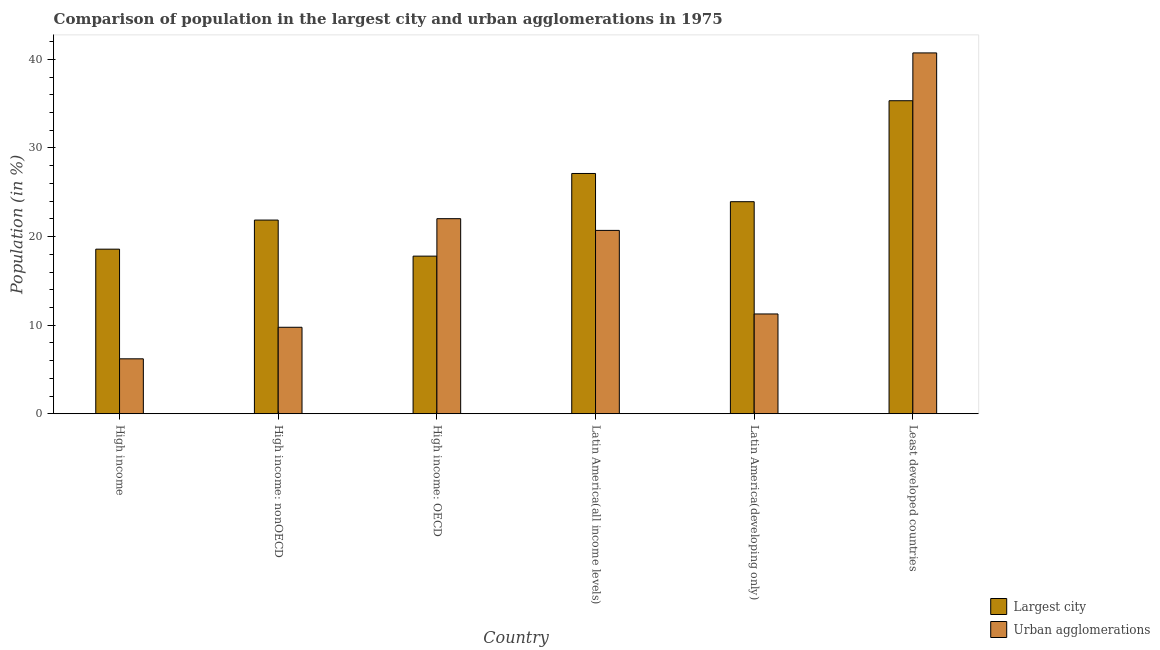How many groups of bars are there?
Ensure brevity in your answer.  6. Are the number of bars per tick equal to the number of legend labels?
Your answer should be compact. Yes. How many bars are there on the 6th tick from the right?
Offer a very short reply. 2. What is the label of the 6th group of bars from the left?
Make the answer very short. Least developed countries. In how many cases, is the number of bars for a given country not equal to the number of legend labels?
Offer a terse response. 0. What is the population in the largest city in Least developed countries?
Provide a succinct answer. 35.34. Across all countries, what is the maximum population in urban agglomerations?
Give a very brief answer. 40.73. Across all countries, what is the minimum population in urban agglomerations?
Provide a succinct answer. 6.2. In which country was the population in the largest city maximum?
Provide a short and direct response. Least developed countries. In which country was the population in the largest city minimum?
Keep it short and to the point. High income: OECD. What is the total population in the largest city in the graph?
Provide a succinct answer. 144.63. What is the difference between the population in the largest city in High income: OECD and that in Latin America(all income levels)?
Keep it short and to the point. -9.33. What is the difference between the population in urban agglomerations in Latin America(all income levels) and the population in the largest city in High income: nonOECD?
Keep it short and to the point. -1.17. What is the average population in urban agglomerations per country?
Provide a short and direct response. 18.45. What is the difference between the population in the largest city and population in urban agglomerations in Latin America(developing only)?
Keep it short and to the point. 12.67. In how many countries, is the population in urban agglomerations greater than 10 %?
Your answer should be compact. 4. What is the ratio of the population in the largest city in High income: OECD to that in Latin America(developing only)?
Your response must be concise. 0.74. Is the population in urban agglomerations in High income: nonOECD less than that in Least developed countries?
Keep it short and to the point. Yes. What is the difference between the highest and the second highest population in urban agglomerations?
Your answer should be compact. 18.71. What is the difference between the highest and the lowest population in the largest city?
Keep it short and to the point. 17.55. What does the 2nd bar from the left in Least developed countries represents?
Give a very brief answer. Urban agglomerations. What does the 2nd bar from the right in High income: nonOECD represents?
Provide a short and direct response. Largest city. How many countries are there in the graph?
Your response must be concise. 6. Are the values on the major ticks of Y-axis written in scientific E-notation?
Your answer should be very brief. No. Does the graph contain any zero values?
Keep it short and to the point. No. How are the legend labels stacked?
Your response must be concise. Vertical. What is the title of the graph?
Offer a very short reply. Comparison of population in the largest city and urban agglomerations in 1975. What is the label or title of the X-axis?
Ensure brevity in your answer.  Country. What is the label or title of the Y-axis?
Provide a short and direct response. Population (in %). What is the Population (in %) in Largest city in High income?
Give a very brief answer. 18.58. What is the Population (in %) of Urban agglomerations in High income?
Keep it short and to the point. 6.2. What is the Population (in %) in Largest city in High income: nonOECD?
Keep it short and to the point. 21.86. What is the Population (in %) in Urban agglomerations in High income: nonOECD?
Offer a very short reply. 9.76. What is the Population (in %) of Largest city in High income: OECD?
Give a very brief answer. 17.79. What is the Population (in %) in Urban agglomerations in High income: OECD?
Your answer should be very brief. 22.02. What is the Population (in %) in Largest city in Latin America(all income levels)?
Provide a short and direct response. 27.12. What is the Population (in %) of Urban agglomerations in Latin America(all income levels)?
Provide a short and direct response. 20.7. What is the Population (in %) of Largest city in Latin America(developing only)?
Your answer should be very brief. 23.94. What is the Population (in %) of Urban agglomerations in Latin America(developing only)?
Your answer should be very brief. 11.26. What is the Population (in %) of Largest city in Least developed countries?
Ensure brevity in your answer.  35.34. What is the Population (in %) in Urban agglomerations in Least developed countries?
Keep it short and to the point. 40.73. Across all countries, what is the maximum Population (in %) of Largest city?
Provide a short and direct response. 35.34. Across all countries, what is the maximum Population (in %) of Urban agglomerations?
Your answer should be compact. 40.73. Across all countries, what is the minimum Population (in %) of Largest city?
Your response must be concise. 17.79. Across all countries, what is the minimum Population (in %) in Urban agglomerations?
Offer a very short reply. 6.2. What is the total Population (in %) of Largest city in the graph?
Your response must be concise. 144.63. What is the total Population (in %) of Urban agglomerations in the graph?
Offer a terse response. 110.68. What is the difference between the Population (in %) in Largest city in High income and that in High income: nonOECD?
Provide a short and direct response. -3.28. What is the difference between the Population (in %) in Urban agglomerations in High income and that in High income: nonOECD?
Make the answer very short. -3.56. What is the difference between the Population (in %) of Largest city in High income and that in High income: OECD?
Your response must be concise. 0.79. What is the difference between the Population (in %) of Urban agglomerations in High income and that in High income: OECD?
Offer a terse response. -15.82. What is the difference between the Population (in %) in Largest city in High income and that in Latin America(all income levels)?
Make the answer very short. -8.54. What is the difference between the Population (in %) of Urban agglomerations in High income and that in Latin America(all income levels)?
Offer a very short reply. -14.5. What is the difference between the Population (in %) of Largest city in High income and that in Latin America(developing only)?
Your response must be concise. -5.36. What is the difference between the Population (in %) of Urban agglomerations in High income and that in Latin America(developing only)?
Make the answer very short. -5.06. What is the difference between the Population (in %) in Largest city in High income and that in Least developed countries?
Keep it short and to the point. -16.76. What is the difference between the Population (in %) of Urban agglomerations in High income and that in Least developed countries?
Your response must be concise. -34.53. What is the difference between the Population (in %) of Largest city in High income: nonOECD and that in High income: OECD?
Provide a succinct answer. 4.07. What is the difference between the Population (in %) in Urban agglomerations in High income: nonOECD and that in High income: OECD?
Ensure brevity in your answer.  -12.26. What is the difference between the Population (in %) in Largest city in High income: nonOECD and that in Latin America(all income levels)?
Keep it short and to the point. -5.26. What is the difference between the Population (in %) of Urban agglomerations in High income: nonOECD and that in Latin America(all income levels)?
Ensure brevity in your answer.  -10.94. What is the difference between the Population (in %) in Largest city in High income: nonOECD and that in Latin America(developing only)?
Make the answer very short. -2.07. What is the difference between the Population (in %) of Urban agglomerations in High income: nonOECD and that in Latin America(developing only)?
Provide a short and direct response. -1.5. What is the difference between the Population (in %) of Largest city in High income: nonOECD and that in Least developed countries?
Your answer should be very brief. -13.47. What is the difference between the Population (in %) of Urban agglomerations in High income: nonOECD and that in Least developed countries?
Offer a very short reply. -30.97. What is the difference between the Population (in %) in Largest city in High income: OECD and that in Latin America(all income levels)?
Ensure brevity in your answer.  -9.33. What is the difference between the Population (in %) of Urban agglomerations in High income: OECD and that in Latin America(all income levels)?
Give a very brief answer. 1.32. What is the difference between the Population (in %) of Largest city in High income: OECD and that in Latin America(developing only)?
Keep it short and to the point. -6.15. What is the difference between the Population (in %) of Urban agglomerations in High income: OECD and that in Latin America(developing only)?
Provide a succinct answer. 10.76. What is the difference between the Population (in %) of Largest city in High income: OECD and that in Least developed countries?
Offer a terse response. -17.55. What is the difference between the Population (in %) in Urban agglomerations in High income: OECD and that in Least developed countries?
Make the answer very short. -18.71. What is the difference between the Population (in %) of Largest city in Latin America(all income levels) and that in Latin America(developing only)?
Offer a terse response. 3.19. What is the difference between the Population (in %) of Urban agglomerations in Latin America(all income levels) and that in Latin America(developing only)?
Your answer should be very brief. 9.43. What is the difference between the Population (in %) in Largest city in Latin America(all income levels) and that in Least developed countries?
Ensure brevity in your answer.  -8.21. What is the difference between the Population (in %) of Urban agglomerations in Latin America(all income levels) and that in Least developed countries?
Provide a short and direct response. -20.04. What is the difference between the Population (in %) in Largest city in Latin America(developing only) and that in Least developed countries?
Keep it short and to the point. -11.4. What is the difference between the Population (in %) in Urban agglomerations in Latin America(developing only) and that in Least developed countries?
Provide a short and direct response. -29.47. What is the difference between the Population (in %) of Largest city in High income and the Population (in %) of Urban agglomerations in High income: nonOECD?
Keep it short and to the point. 8.82. What is the difference between the Population (in %) in Largest city in High income and the Population (in %) in Urban agglomerations in High income: OECD?
Provide a succinct answer. -3.44. What is the difference between the Population (in %) in Largest city in High income and the Population (in %) in Urban agglomerations in Latin America(all income levels)?
Your answer should be very brief. -2.12. What is the difference between the Population (in %) of Largest city in High income and the Population (in %) of Urban agglomerations in Latin America(developing only)?
Ensure brevity in your answer.  7.32. What is the difference between the Population (in %) in Largest city in High income and the Population (in %) in Urban agglomerations in Least developed countries?
Offer a very short reply. -22.15. What is the difference between the Population (in %) of Largest city in High income: nonOECD and the Population (in %) of Urban agglomerations in High income: OECD?
Make the answer very short. -0.16. What is the difference between the Population (in %) in Largest city in High income: nonOECD and the Population (in %) in Urban agglomerations in Latin America(all income levels)?
Make the answer very short. 1.17. What is the difference between the Population (in %) in Largest city in High income: nonOECD and the Population (in %) in Urban agglomerations in Latin America(developing only)?
Give a very brief answer. 10.6. What is the difference between the Population (in %) in Largest city in High income: nonOECD and the Population (in %) in Urban agglomerations in Least developed countries?
Your answer should be very brief. -18.87. What is the difference between the Population (in %) in Largest city in High income: OECD and the Population (in %) in Urban agglomerations in Latin America(all income levels)?
Your response must be concise. -2.91. What is the difference between the Population (in %) in Largest city in High income: OECD and the Population (in %) in Urban agglomerations in Latin America(developing only)?
Your answer should be very brief. 6.53. What is the difference between the Population (in %) of Largest city in High income: OECD and the Population (in %) of Urban agglomerations in Least developed countries?
Provide a short and direct response. -22.94. What is the difference between the Population (in %) of Largest city in Latin America(all income levels) and the Population (in %) of Urban agglomerations in Latin America(developing only)?
Make the answer very short. 15.86. What is the difference between the Population (in %) in Largest city in Latin America(all income levels) and the Population (in %) in Urban agglomerations in Least developed countries?
Ensure brevity in your answer.  -13.61. What is the difference between the Population (in %) of Largest city in Latin America(developing only) and the Population (in %) of Urban agglomerations in Least developed countries?
Provide a succinct answer. -16.8. What is the average Population (in %) of Largest city per country?
Keep it short and to the point. 24.11. What is the average Population (in %) in Urban agglomerations per country?
Keep it short and to the point. 18.45. What is the difference between the Population (in %) in Largest city and Population (in %) in Urban agglomerations in High income?
Keep it short and to the point. 12.38. What is the difference between the Population (in %) in Largest city and Population (in %) in Urban agglomerations in High income: nonOECD?
Provide a short and direct response. 12.1. What is the difference between the Population (in %) of Largest city and Population (in %) of Urban agglomerations in High income: OECD?
Your answer should be compact. -4.23. What is the difference between the Population (in %) in Largest city and Population (in %) in Urban agglomerations in Latin America(all income levels)?
Your answer should be very brief. 6.43. What is the difference between the Population (in %) of Largest city and Population (in %) of Urban agglomerations in Latin America(developing only)?
Your answer should be very brief. 12.67. What is the difference between the Population (in %) in Largest city and Population (in %) in Urban agglomerations in Least developed countries?
Give a very brief answer. -5.4. What is the ratio of the Population (in %) of Largest city in High income to that in High income: nonOECD?
Provide a short and direct response. 0.85. What is the ratio of the Population (in %) in Urban agglomerations in High income to that in High income: nonOECD?
Keep it short and to the point. 0.64. What is the ratio of the Population (in %) of Largest city in High income to that in High income: OECD?
Your answer should be very brief. 1.04. What is the ratio of the Population (in %) of Urban agglomerations in High income to that in High income: OECD?
Your response must be concise. 0.28. What is the ratio of the Population (in %) in Largest city in High income to that in Latin America(all income levels)?
Your response must be concise. 0.69. What is the ratio of the Population (in %) in Urban agglomerations in High income to that in Latin America(all income levels)?
Offer a very short reply. 0.3. What is the ratio of the Population (in %) of Largest city in High income to that in Latin America(developing only)?
Ensure brevity in your answer.  0.78. What is the ratio of the Population (in %) of Urban agglomerations in High income to that in Latin America(developing only)?
Keep it short and to the point. 0.55. What is the ratio of the Population (in %) in Largest city in High income to that in Least developed countries?
Keep it short and to the point. 0.53. What is the ratio of the Population (in %) of Urban agglomerations in High income to that in Least developed countries?
Your response must be concise. 0.15. What is the ratio of the Population (in %) of Largest city in High income: nonOECD to that in High income: OECD?
Your answer should be compact. 1.23. What is the ratio of the Population (in %) of Urban agglomerations in High income: nonOECD to that in High income: OECD?
Your answer should be very brief. 0.44. What is the ratio of the Population (in %) of Largest city in High income: nonOECD to that in Latin America(all income levels)?
Give a very brief answer. 0.81. What is the ratio of the Population (in %) in Urban agglomerations in High income: nonOECD to that in Latin America(all income levels)?
Ensure brevity in your answer.  0.47. What is the ratio of the Population (in %) of Largest city in High income: nonOECD to that in Latin America(developing only)?
Give a very brief answer. 0.91. What is the ratio of the Population (in %) of Urban agglomerations in High income: nonOECD to that in Latin America(developing only)?
Offer a very short reply. 0.87. What is the ratio of the Population (in %) in Largest city in High income: nonOECD to that in Least developed countries?
Your response must be concise. 0.62. What is the ratio of the Population (in %) of Urban agglomerations in High income: nonOECD to that in Least developed countries?
Make the answer very short. 0.24. What is the ratio of the Population (in %) of Largest city in High income: OECD to that in Latin America(all income levels)?
Provide a succinct answer. 0.66. What is the ratio of the Population (in %) of Urban agglomerations in High income: OECD to that in Latin America(all income levels)?
Give a very brief answer. 1.06. What is the ratio of the Population (in %) of Largest city in High income: OECD to that in Latin America(developing only)?
Provide a short and direct response. 0.74. What is the ratio of the Population (in %) of Urban agglomerations in High income: OECD to that in Latin America(developing only)?
Provide a succinct answer. 1.95. What is the ratio of the Population (in %) in Largest city in High income: OECD to that in Least developed countries?
Offer a very short reply. 0.5. What is the ratio of the Population (in %) of Urban agglomerations in High income: OECD to that in Least developed countries?
Offer a very short reply. 0.54. What is the ratio of the Population (in %) of Largest city in Latin America(all income levels) to that in Latin America(developing only)?
Your response must be concise. 1.13. What is the ratio of the Population (in %) in Urban agglomerations in Latin America(all income levels) to that in Latin America(developing only)?
Make the answer very short. 1.84. What is the ratio of the Population (in %) of Largest city in Latin America(all income levels) to that in Least developed countries?
Provide a succinct answer. 0.77. What is the ratio of the Population (in %) of Urban agglomerations in Latin America(all income levels) to that in Least developed countries?
Keep it short and to the point. 0.51. What is the ratio of the Population (in %) of Largest city in Latin America(developing only) to that in Least developed countries?
Keep it short and to the point. 0.68. What is the ratio of the Population (in %) of Urban agglomerations in Latin America(developing only) to that in Least developed countries?
Provide a short and direct response. 0.28. What is the difference between the highest and the second highest Population (in %) of Largest city?
Your answer should be very brief. 8.21. What is the difference between the highest and the second highest Population (in %) of Urban agglomerations?
Offer a very short reply. 18.71. What is the difference between the highest and the lowest Population (in %) in Largest city?
Give a very brief answer. 17.55. What is the difference between the highest and the lowest Population (in %) of Urban agglomerations?
Offer a terse response. 34.53. 